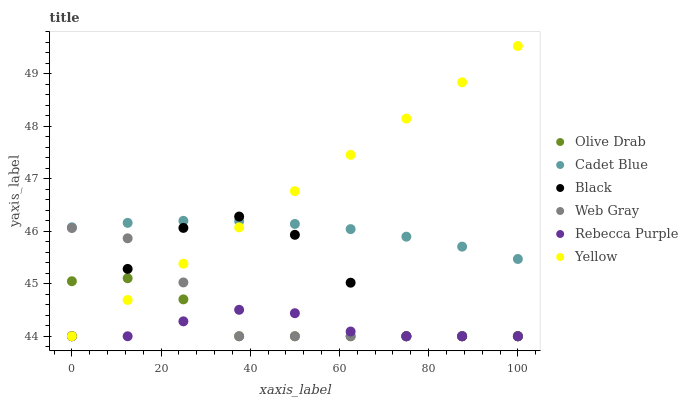Does Rebecca Purple have the minimum area under the curve?
Answer yes or no. Yes. Does Yellow have the maximum area under the curve?
Answer yes or no. Yes. Does Cadet Blue have the minimum area under the curve?
Answer yes or no. No. Does Cadet Blue have the maximum area under the curve?
Answer yes or no. No. Is Yellow the smoothest?
Answer yes or no. Yes. Is Black the roughest?
Answer yes or no. Yes. Is Cadet Blue the smoothest?
Answer yes or no. No. Is Cadet Blue the roughest?
Answer yes or no. No. Does Web Gray have the lowest value?
Answer yes or no. Yes. Does Cadet Blue have the lowest value?
Answer yes or no. No. Does Yellow have the highest value?
Answer yes or no. Yes. Does Cadet Blue have the highest value?
Answer yes or no. No. Is Web Gray less than Cadet Blue?
Answer yes or no. Yes. Is Cadet Blue greater than Rebecca Purple?
Answer yes or no. Yes. Does Yellow intersect Black?
Answer yes or no. Yes. Is Yellow less than Black?
Answer yes or no. No. Is Yellow greater than Black?
Answer yes or no. No. Does Web Gray intersect Cadet Blue?
Answer yes or no. No. 